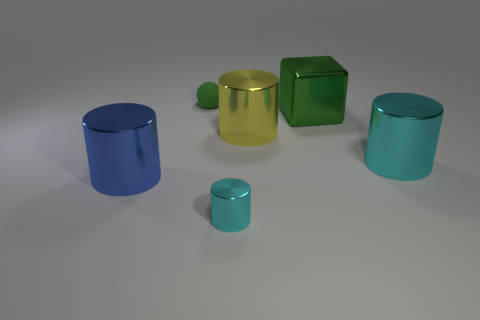Do the metal object that is right of the metal cube and the small metallic object have the same color?
Keep it short and to the point. Yes. There is a tiny object behind the cube; what is its material?
Keep it short and to the point. Rubber. Are there the same number of blue metallic things right of the small sphere and purple metal blocks?
Provide a succinct answer. Yes. What number of spheres are the same color as the large metallic cube?
Give a very brief answer. 1. What color is the tiny metal object that is the same shape as the big cyan metal thing?
Your response must be concise. Cyan. Do the sphere and the green metal thing have the same size?
Your answer should be very brief. No. Are there an equal number of metal cubes on the right side of the large green thing and yellow cylinders that are in front of the small metal cylinder?
Provide a succinct answer. Yes. Are any big purple cylinders visible?
Give a very brief answer. No. There is a yellow thing that is the same shape as the blue object; what is its size?
Your response must be concise. Large. There is a metallic cylinder in front of the big blue metallic cylinder; how big is it?
Your answer should be compact. Small. 